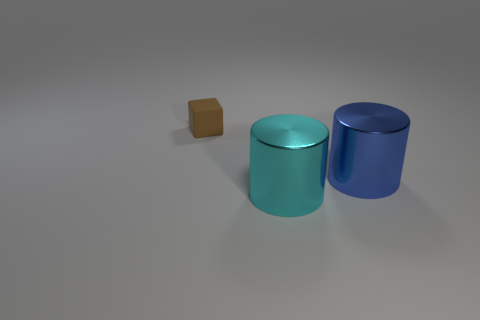Add 3 green spheres. How many objects exist? 6 Subtract all cylinders. How many objects are left? 1 Subtract all big purple matte blocks. Subtract all tiny brown blocks. How many objects are left? 2 Add 1 small matte objects. How many small matte objects are left? 2 Add 2 gray metallic cylinders. How many gray metallic cylinders exist? 2 Subtract 0 blue balls. How many objects are left? 3 